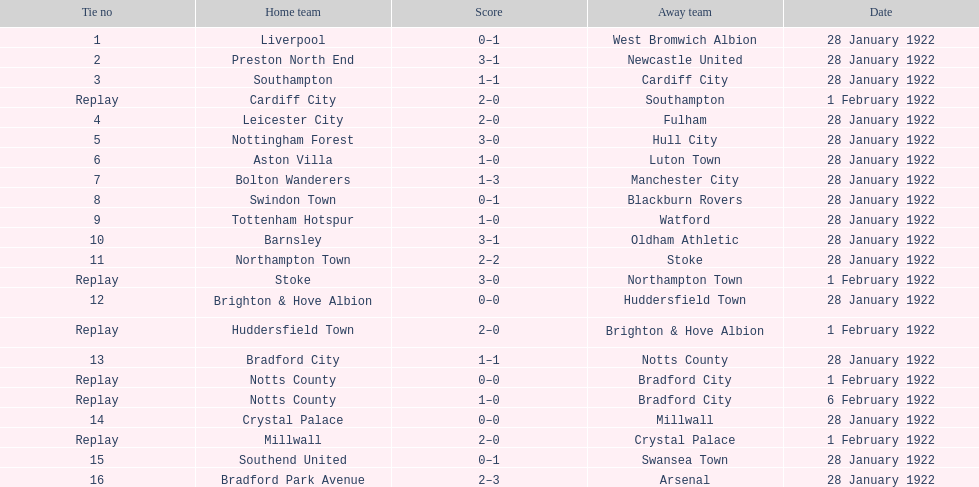In which game were more goals scored in total, 1 or 16? 16. 